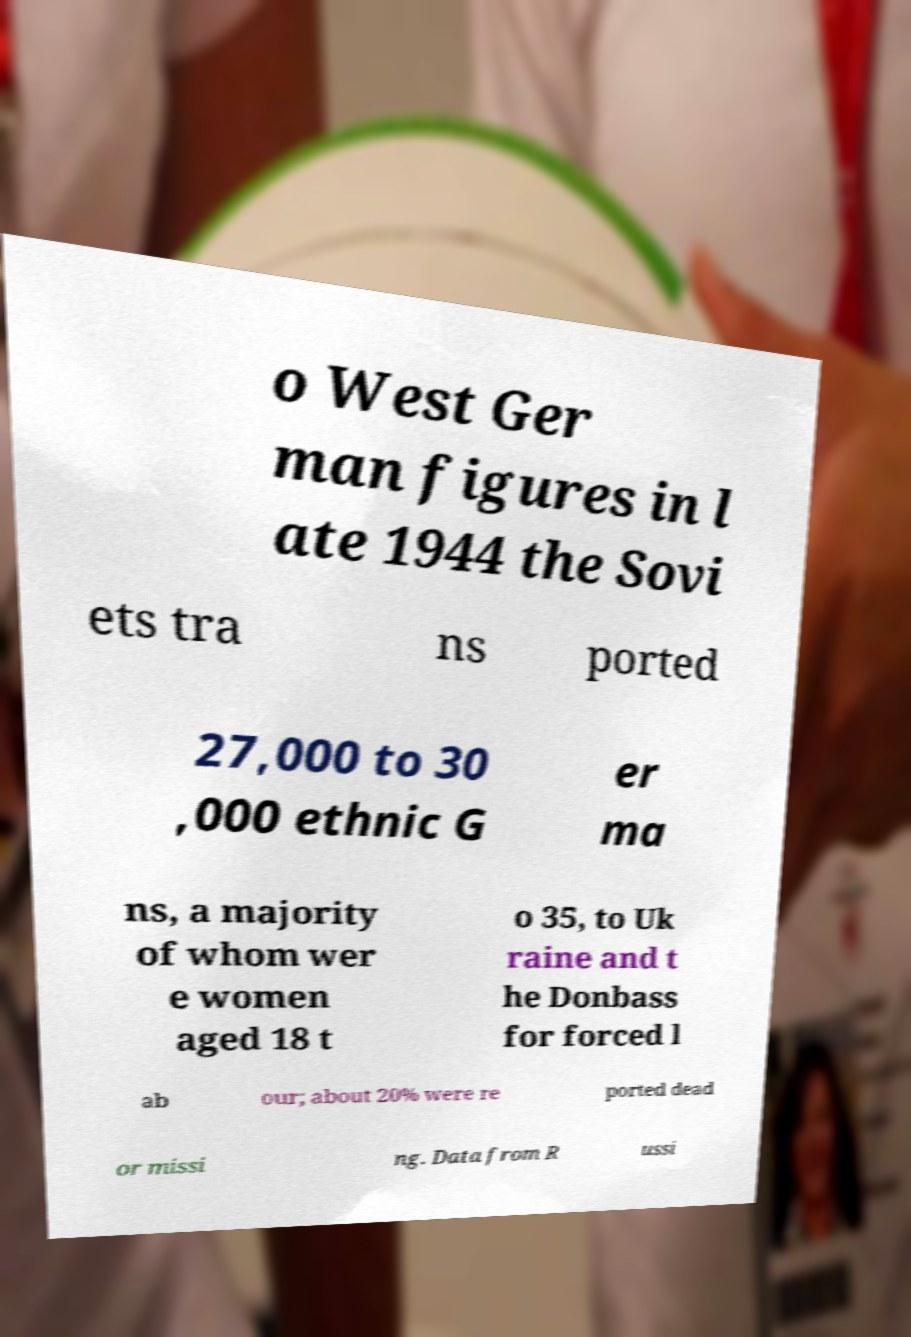Could you assist in decoding the text presented in this image and type it out clearly? o West Ger man figures in l ate 1944 the Sovi ets tra ns ported 27,000 to 30 ,000 ethnic G er ma ns, a majority of whom wer e women aged 18 t o 35, to Uk raine and t he Donbass for forced l ab our; about 20% were re ported dead or missi ng. Data from R ussi 